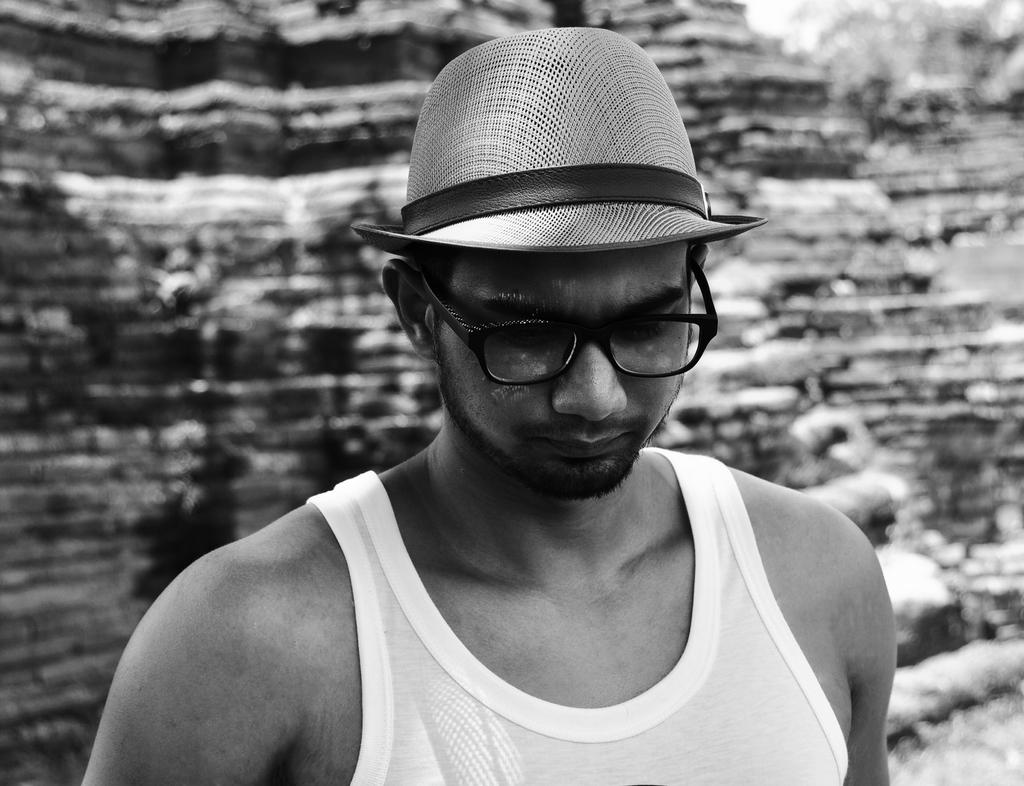What can be seen in the image? There is a person in the image. Can you describe the person's appearance? The person is wearing a hat and spectacles. What can be observed about the background of the image? The background of the image is blurry. What type of pot is being used in the process depicted in the image? There is no pot or process present in the image; it features a person wearing a hat and spectacles against a blurry background. 